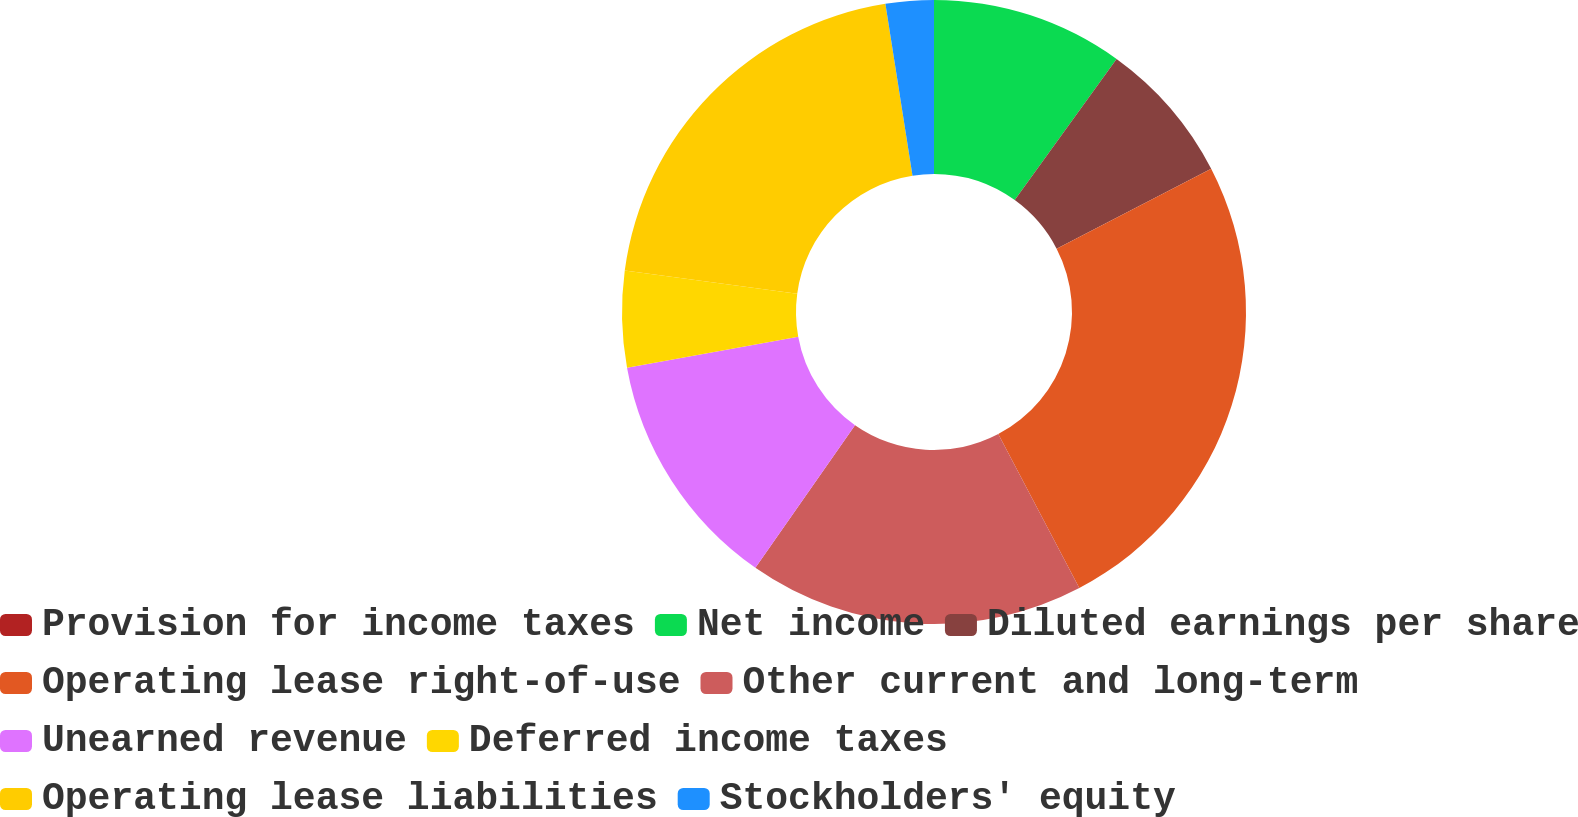<chart> <loc_0><loc_0><loc_500><loc_500><pie_chart><fcel>Provision for income taxes<fcel>Net income<fcel>Diluted earnings per share<fcel>Operating lease right-of-use<fcel>Other current and long-term<fcel>Unearned revenue<fcel>Deferred income taxes<fcel>Operating lease liabilities<fcel>Stockholders' equity<nl><fcel>0.0%<fcel>9.95%<fcel>7.46%<fcel>24.88%<fcel>17.41%<fcel>12.44%<fcel>4.98%<fcel>20.39%<fcel>2.49%<nl></chart> 